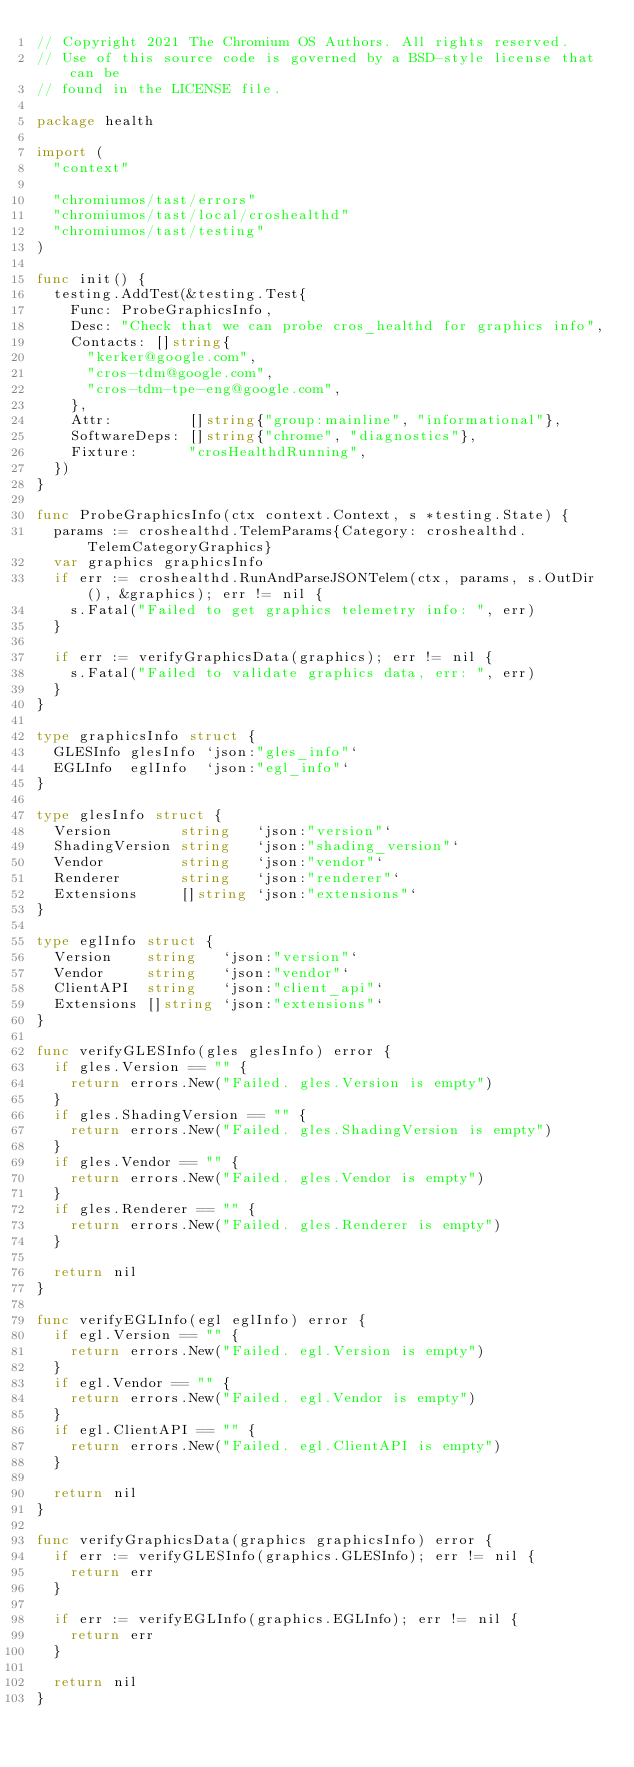Convert code to text. <code><loc_0><loc_0><loc_500><loc_500><_Go_>// Copyright 2021 The Chromium OS Authors. All rights reserved.
// Use of this source code is governed by a BSD-style license that can be
// found in the LICENSE file.

package health

import (
	"context"

	"chromiumos/tast/errors"
	"chromiumos/tast/local/croshealthd"
	"chromiumos/tast/testing"
)

func init() {
	testing.AddTest(&testing.Test{
		Func: ProbeGraphicsInfo,
		Desc: "Check that we can probe cros_healthd for graphics info",
		Contacts: []string{
			"kerker@google.com",
			"cros-tdm@google.com",
			"cros-tdm-tpe-eng@google.com",
		},
		Attr:         []string{"group:mainline", "informational"},
		SoftwareDeps: []string{"chrome", "diagnostics"},
		Fixture:      "crosHealthdRunning",
	})
}

func ProbeGraphicsInfo(ctx context.Context, s *testing.State) {
	params := croshealthd.TelemParams{Category: croshealthd.TelemCategoryGraphics}
	var graphics graphicsInfo
	if err := croshealthd.RunAndParseJSONTelem(ctx, params, s.OutDir(), &graphics); err != nil {
		s.Fatal("Failed to get graphics telemetry info: ", err)
	}

	if err := verifyGraphicsData(graphics); err != nil {
		s.Fatal("Failed to validate graphics data, err: ", err)
	}
}

type graphicsInfo struct {
	GLESInfo glesInfo `json:"gles_info"`
	EGLInfo  eglInfo  `json:"egl_info"`
}

type glesInfo struct {
	Version        string   `json:"version"`
	ShadingVersion string   `json:"shading_version"`
	Vendor         string   `json:"vendor"`
	Renderer       string   `json:"renderer"`
	Extensions     []string `json:"extensions"`
}

type eglInfo struct {
	Version    string   `json:"version"`
	Vendor     string   `json:"vendor"`
	ClientAPI  string   `json:"client_api"`
	Extensions []string `json:"extensions"`
}

func verifyGLESInfo(gles glesInfo) error {
	if gles.Version == "" {
		return errors.New("Failed. gles.Version is empty")
	}
	if gles.ShadingVersion == "" {
		return errors.New("Failed. gles.ShadingVersion is empty")
	}
	if gles.Vendor == "" {
		return errors.New("Failed. gles.Vendor is empty")
	}
	if gles.Renderer == "" {
		return errors.New("Failed. gles.Renderer is empty")
	}

	return nil
}

func verifyEGLInfo(egl eglInfo) error {
	if egl.Version == "" {
		return errors.New("Failed. egl.Version is empty")
	}
	if egl.Vendor == "" {
		return errors.New("Failed. egl.Vendor is empty")
	}
	if egl.ClientAPI == "" {
		return errors.New("Failed. egl.ClientAPI is empty")
	}

	return nil
}

func verifyGraphicsData(graphics graphicsInfo) error {
	if err := verifyGLESInfo(graphics.GLESInfo); err != nil {
		return err
	}

	if err := verifyEGLInfo(graphics.EGLInfo); err != nil {
		return err
	}

	return nil
}
</code> 